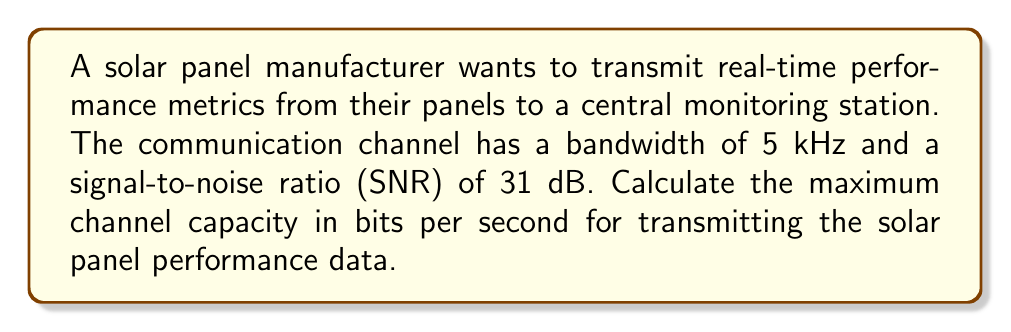Can you solve this math problem? To solve this problem, we'll use the Shannon-Hartley theorem, which gives the channel capacity for a communication channel with Gaussian noise:

$$C = B \log_2(1 + SNR)$$

Where:
$C$ = Channel capacity (bits per second)
$B$ = Bandwidth (Hz)
$SNR$ = Signal-to-noise ratio (linear scale)

Given:
- Bandwidth $(B) = 5$ kHz $= 5000$ Hz
- SNR $= 31$ dB

Step 1: Convert SNR from dB to linear scale
The SNR in dB is related to the linear SNR by:
$SNR_{dB} = 10 \log_{10}(SNR_{linear})$

Rearranging:
$SNR_{linear} = 10^{SNR_{dB}/10}$

$SNR_{linear} = 10^{31/10} \approx 1258.93$

Step 2: Apply the Shannon-Hartley theorem
$$\begin{align}
C &= B \log_2(1 + SNR) \\
&= 5000 \log_2(1 + 1258.93) \\
&= 5000 \log_2(1259.93) \\
&\approx 5000 \times 10.30 \\
&\approx 51,500 \text{ bits per second}
\end{align}$$

Therefore, the maximum channel capacity for transmitting real-time solar panel performance metrics is approximately 51,500 bits per second.
Answer: 51,500 bits per second 